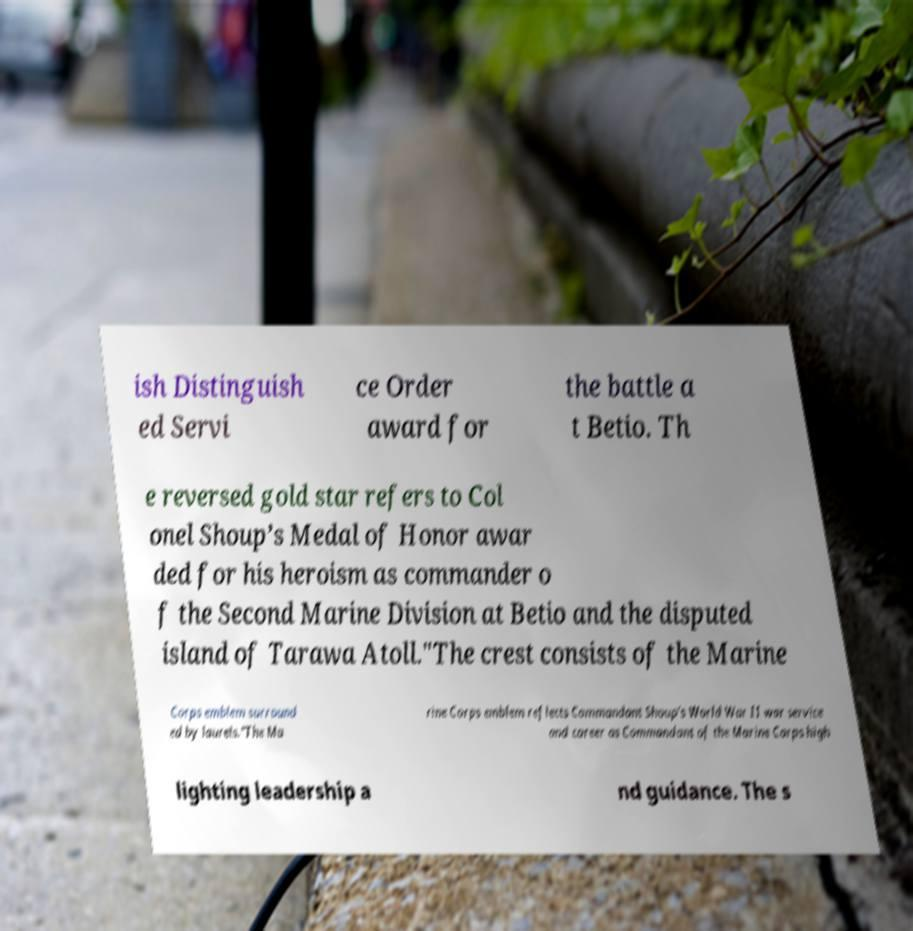Can you accurately transcribe the text from the provided image for me? ish Distinguish ed Servi ce Order award for the battle a t Betio. Th e reversed gold star refers to Col onel Shoup’s Medal of Honor awar ded for his heroism as commander o f the Second Marine Division at Betio and the disputed island of Tarawa Atoll."The crest consists of the Marine Corps emblem surround ed by laurels."The Ma rine Corps emblem reflects Commandant Shoup’s World War II war service and career as Commandant of the Marine Corps high lighting leadership a nd guidance. The s 